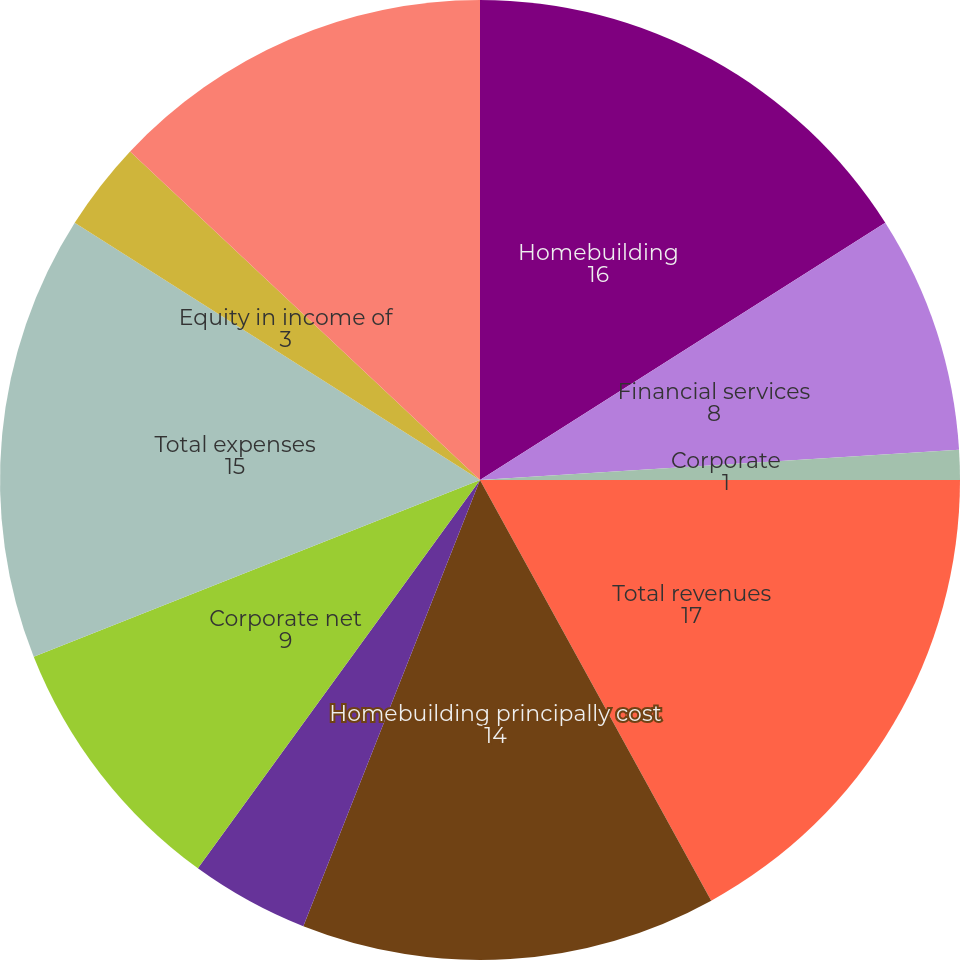Convert chart to OTSL. <chart><loc_0><loc_0><loc_500><loc_500><pie_chart><fcel>Homebuilding<fcel>Financial services<fcel>Corporate<fcel>Total revenues<fcel>Homebuilding principally cost<fcel>Financial services principally<fcel>Corporate net<fcel>Total expenses<fcel>Equity in income of<fcel>Income from continuing<nl><fcel>16.0%<fcel>8.0%<fcel>1.0%<fcel>17.0%<fcel>14.0%<fcel>4.0%<fcel>9.0%<fcel>15.0%<fcel>3.0%<fcel>13.0%<nl></chart> 